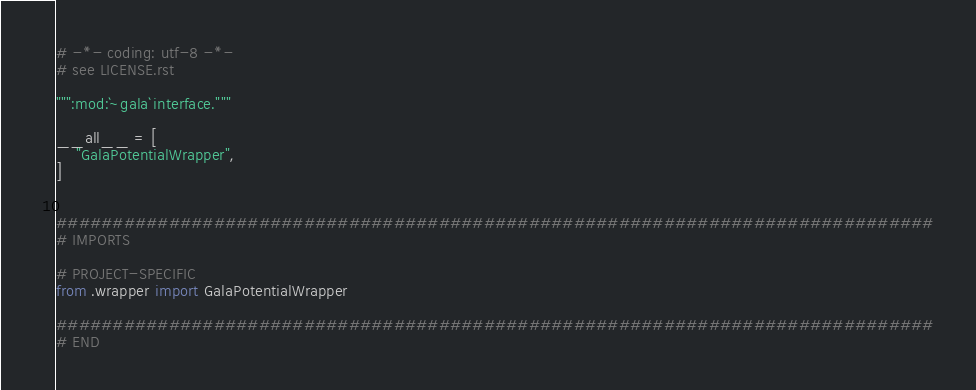<code> <loc_0><loc_0><loc_500><loc_500><_Python_># -*- coding: utf-8 -*-
# see LICENSE.rst

""":mod:`~gala` interface."""

__all__ = [
    "GalaPotentialWrapper",
]


##############################################################################
# IMPORTS

# PROJECT-SPECIFIC
from .wrapper import GalaPotentialWrapper

##############################################################################
# END
</code> 